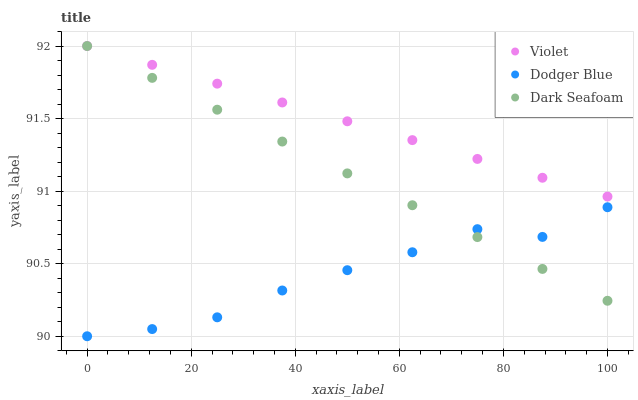Does Dodger Blue have the minimum area under the curve?
Answer yes or no. Yes. Does Violet have the maximum area under the curve?
Answer yes or no. Yes. Does Violet have the minimum area under the curve?
Answer yes or no. No. Does Dodger Blue have the maximum area under the curve?
Answer yes or no. No. Is Violet the smoothest?
Answer yes or no. Yes. Is Dodger Blue the roughest?
Answer yes or no. Yes. Is Dodger Blue the smoothest?
Answer yes or no. No. Is Violet the roughest?
Answer yes or no. No. Does Dodger Blue have the lowest value?
Answer yes or no. Yes. Does Violet have the lowest value?
Answer yes or no. No. Does Violet have the highest value?
Answer yes or no. Yes. Does Dodger Blue have the highest value?
Answer yes or no. No. Is Dodger Blue less than Violet?
Answer yes or no. Yes. Is Violet greater than Dodger Blue?
Answer yes or no. Yes. Does Dark Seafoam intersect Violet?
Answer yes or no. Yes. Is Dark Seafoam less than Violet?
Answer yes or no. No. Is Dark Seafoam greater than Violet?
Answer yes or no. No. Does Dodger Blue intersect Violet?
Answer yes or no. No. 